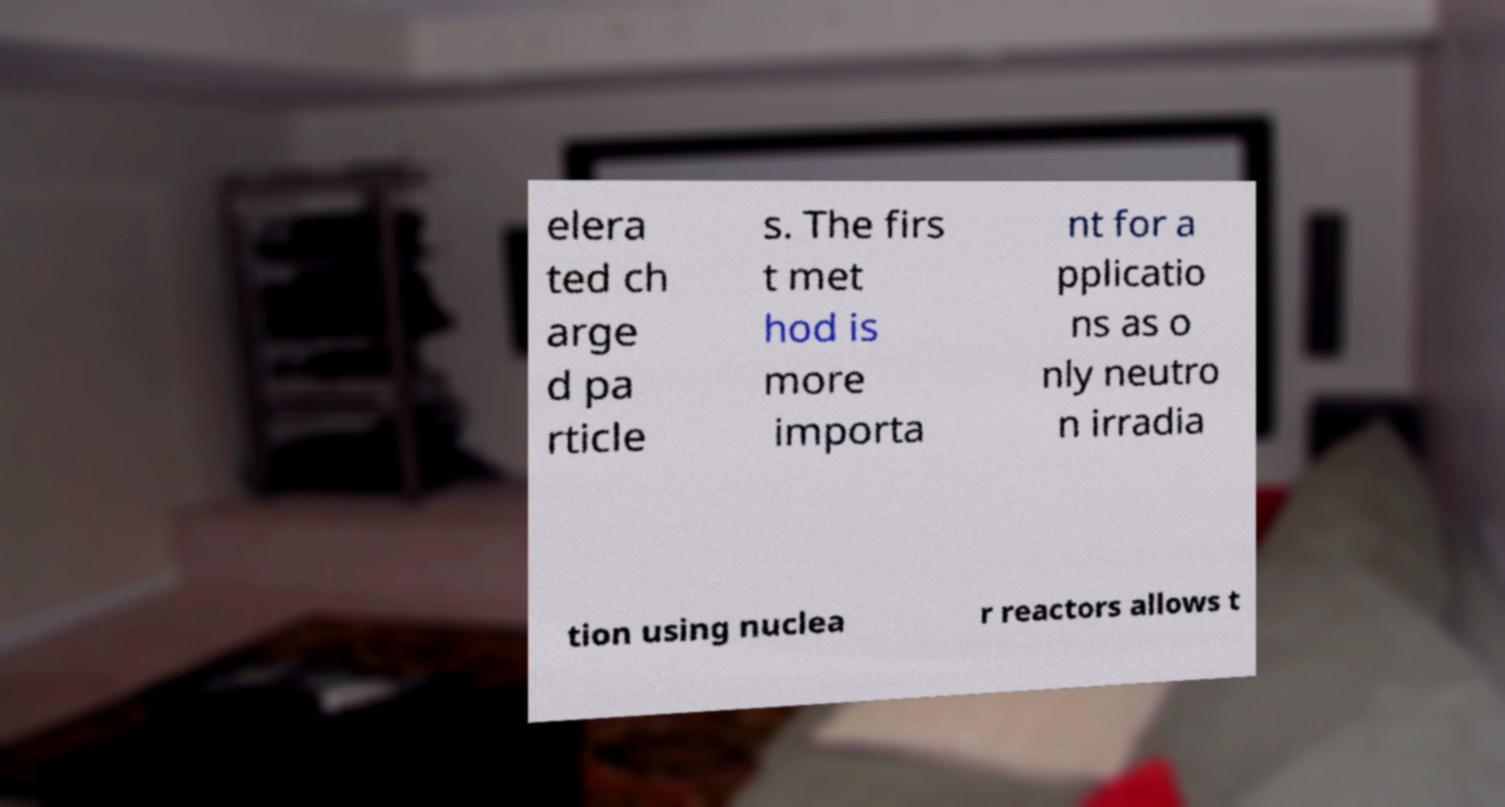What messages or text are displayed in this image? I need them in a readable, typed format. elera ted ch arge d pa rticle s. The firs t met hod is more importa nt for a pplicatio ns as o nly neutro n irradia tion using nuclea r reactors allows t 